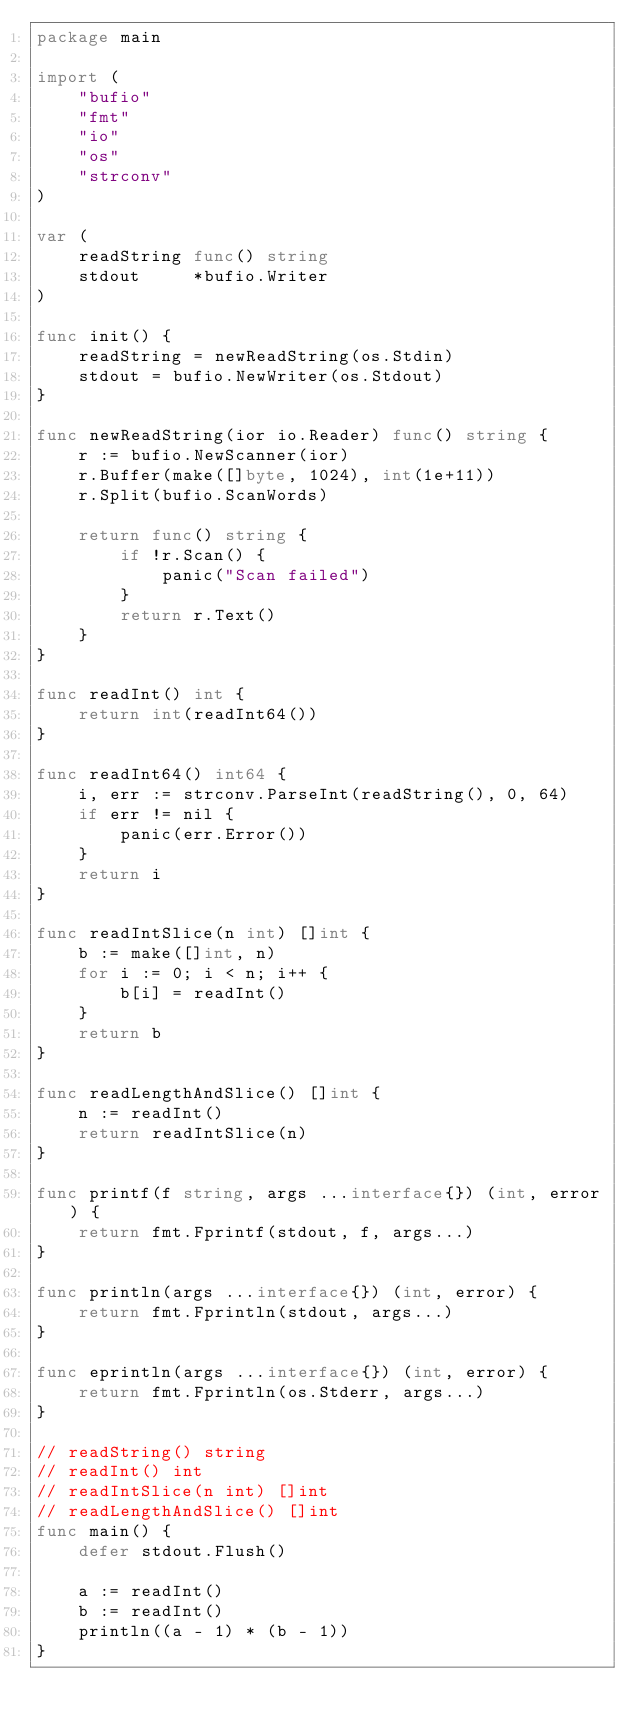Convert code to text. <code><loc_0><loc_0><loc_500><loc_500><_Go_>package main

import (
	"bufio"
	"fmt"
	"io"
	"os"
	"strconv"
)

var (
	readString func() string
	stdout     *bufio.Writer
)

func init() {
	readString = newReadString(os.Stdin)
	stdout = bufio.NewWriter(os.Stdout)
}

func newReadString(ior io.Reader) func() string {
	r := bufio.NewScanner(ior)
	r.Buffer(make([]byte, 1024), int(1e+11))
	r.Split(bufio.ScanWords)

	return func() string {
		if !r.Scan() {
			panic("Scan failed")
		}
		return r.Text()
	}
}

func readInt() int {
	return int(readInt64())
}

func readInt64() int64 {
	i, err := strconv.ParseInt(readString(), 0, 64)
	if err != nil {
		panic(err.Error())
	}
	return i
}

func readIntSlice(n int) []int {
	b := make([]int, n)
	for i := 0; i < n; i++ {
		b[i] = readInt()
	}
	return b
}

func readLengthAndSlice() []int {
	n := readInt()
	return readIntSlice(n)
}

func printf(f string, args ...interface{}) (int, error) {
	return fmt.Fprintf(stdout, f, args...)
}

func println(args ...interface{}) (int, error) {
	return fmt.Fprintln(stdout, args...)
}

func eprintln(args ...interface{}) (int, error) {
	return fmt.Fprintln(os.Stderr, args...)
}

// readString() string
// readInt() int
// readIntSlice(n int) []int
// readLengthAndSlice() []int
func main() {
	defer stdout.Flush()

	a := readInt()
	b := readInt()
	println((a - 1) * (b - 1))
}
</code> 